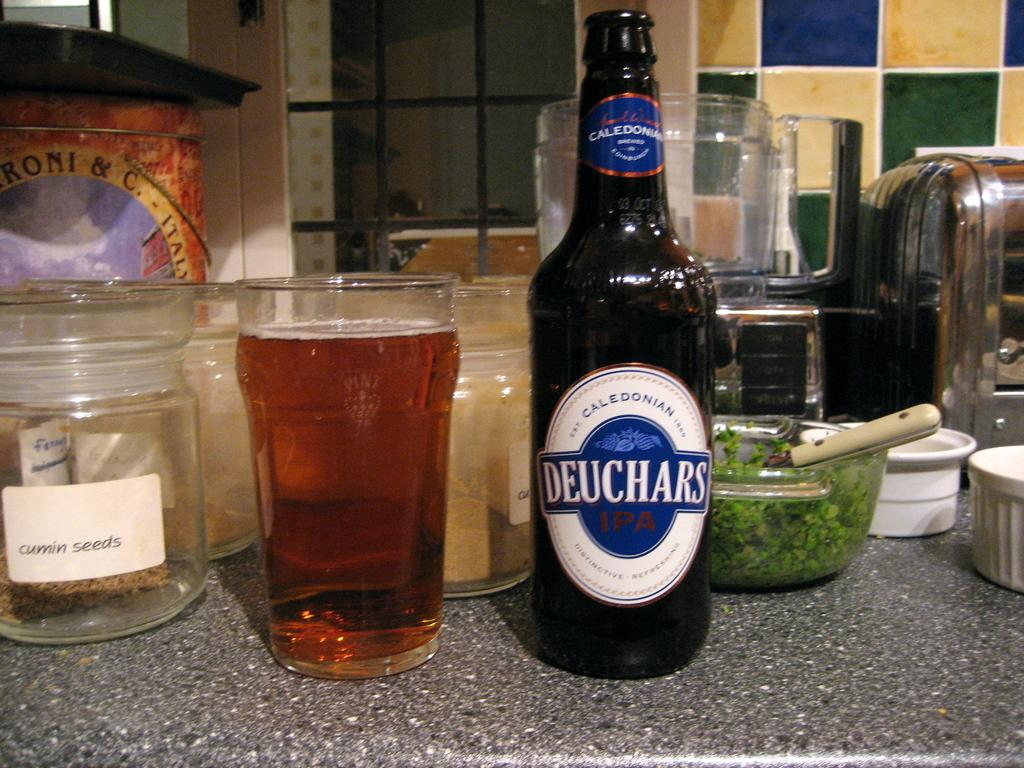<image>
Provide a brief description of the given image. A Deuchars branded beer poured into a glass. 